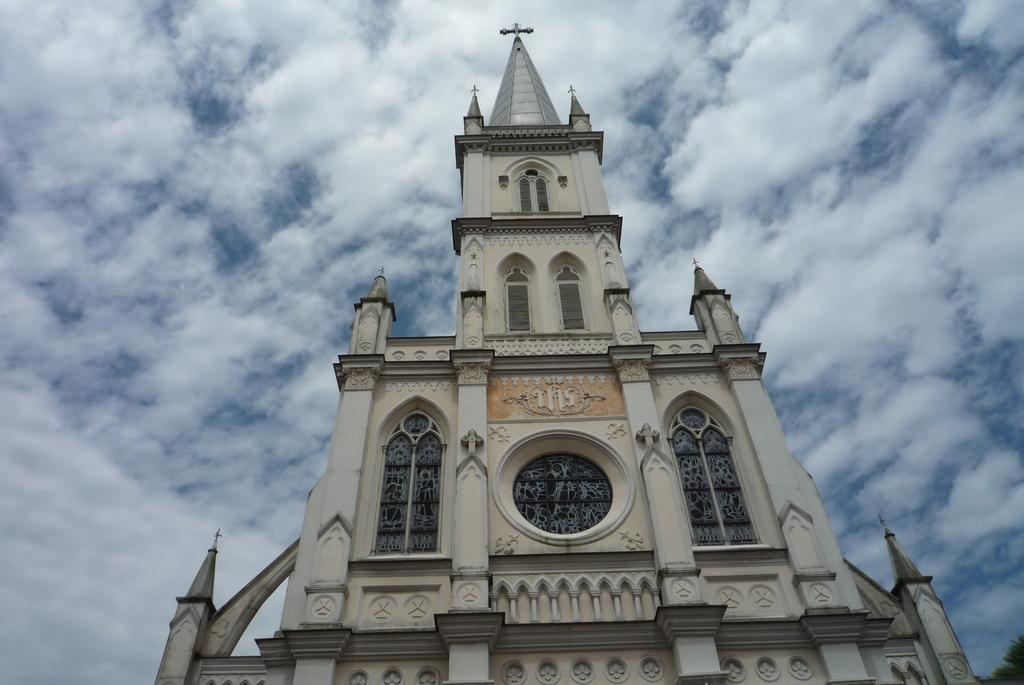What type of structure is the main subject of the image? There is a castle in the image. Where is the castle located in relation to the image? The castle is in the front of the image. What type of vegetation can be seen on the right side of the image? There are leaves on the right side of the image. What is the condition of the sky in the image? The sky is cloudy in the image. What type of desk can be seen in the image? There is no desk present in the image; it features a castle and leaves. What type of destruction is happening to the castle in the image? There is no destruction happening to the castle in the image; it appears to be intact. 